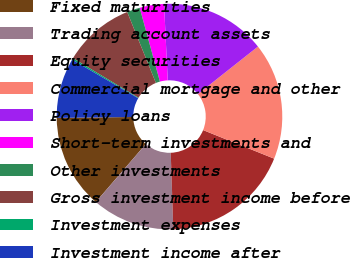Convert chart. <chart><loc_0><loc_0><loc_500><loc_500><pie_chart><fcel>Fixed maturities<fcel>Trading account assets<fcel>Equity securities<fcel>Commercial mortgage and other<fcel>Policy loans<fcel>Short-term investments and<fcel>Other investments<fcel>Gross investment income before<fcel>Investment expenses<fcel>Investment income after<nl><fcel>13.49%<fcel>11.86%<fcel>18.37%<fcel>16.74%<fcel>15.11%<fcel>3.49%<fcel>1.86%<fcel>10.23%<fcel>0.23%<fcel>8.61%<nl></chart> 